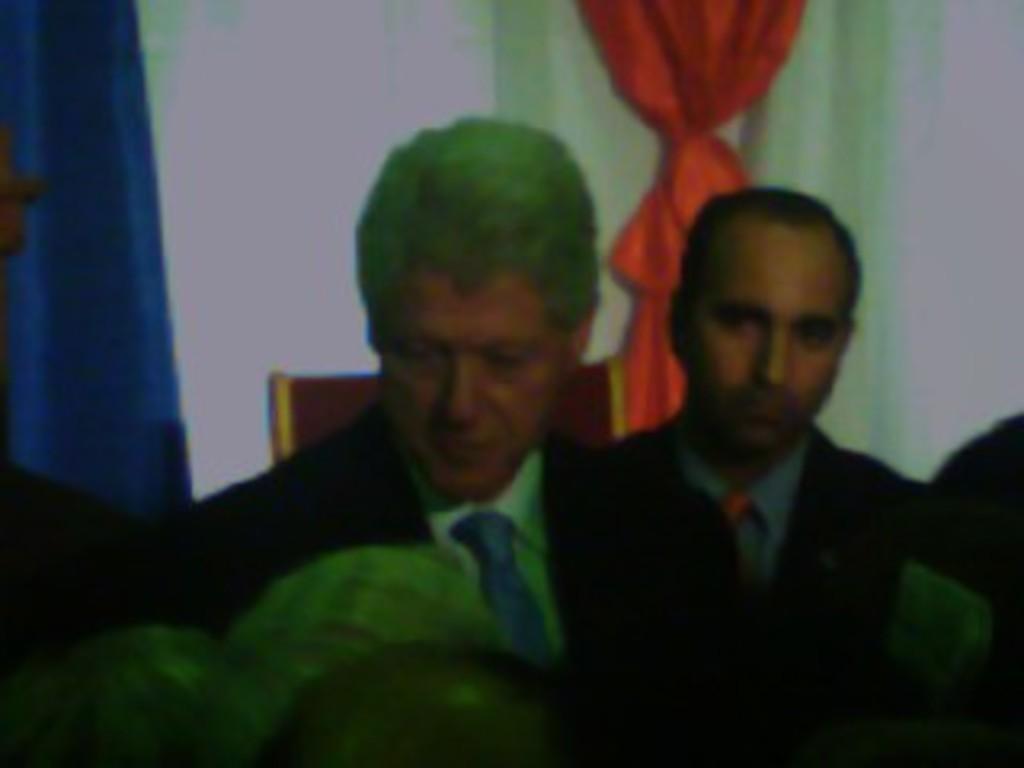How would you summarize this image in a sentence or two? In this image we can see two men. In the background we can see wall, chair and a curtain. 